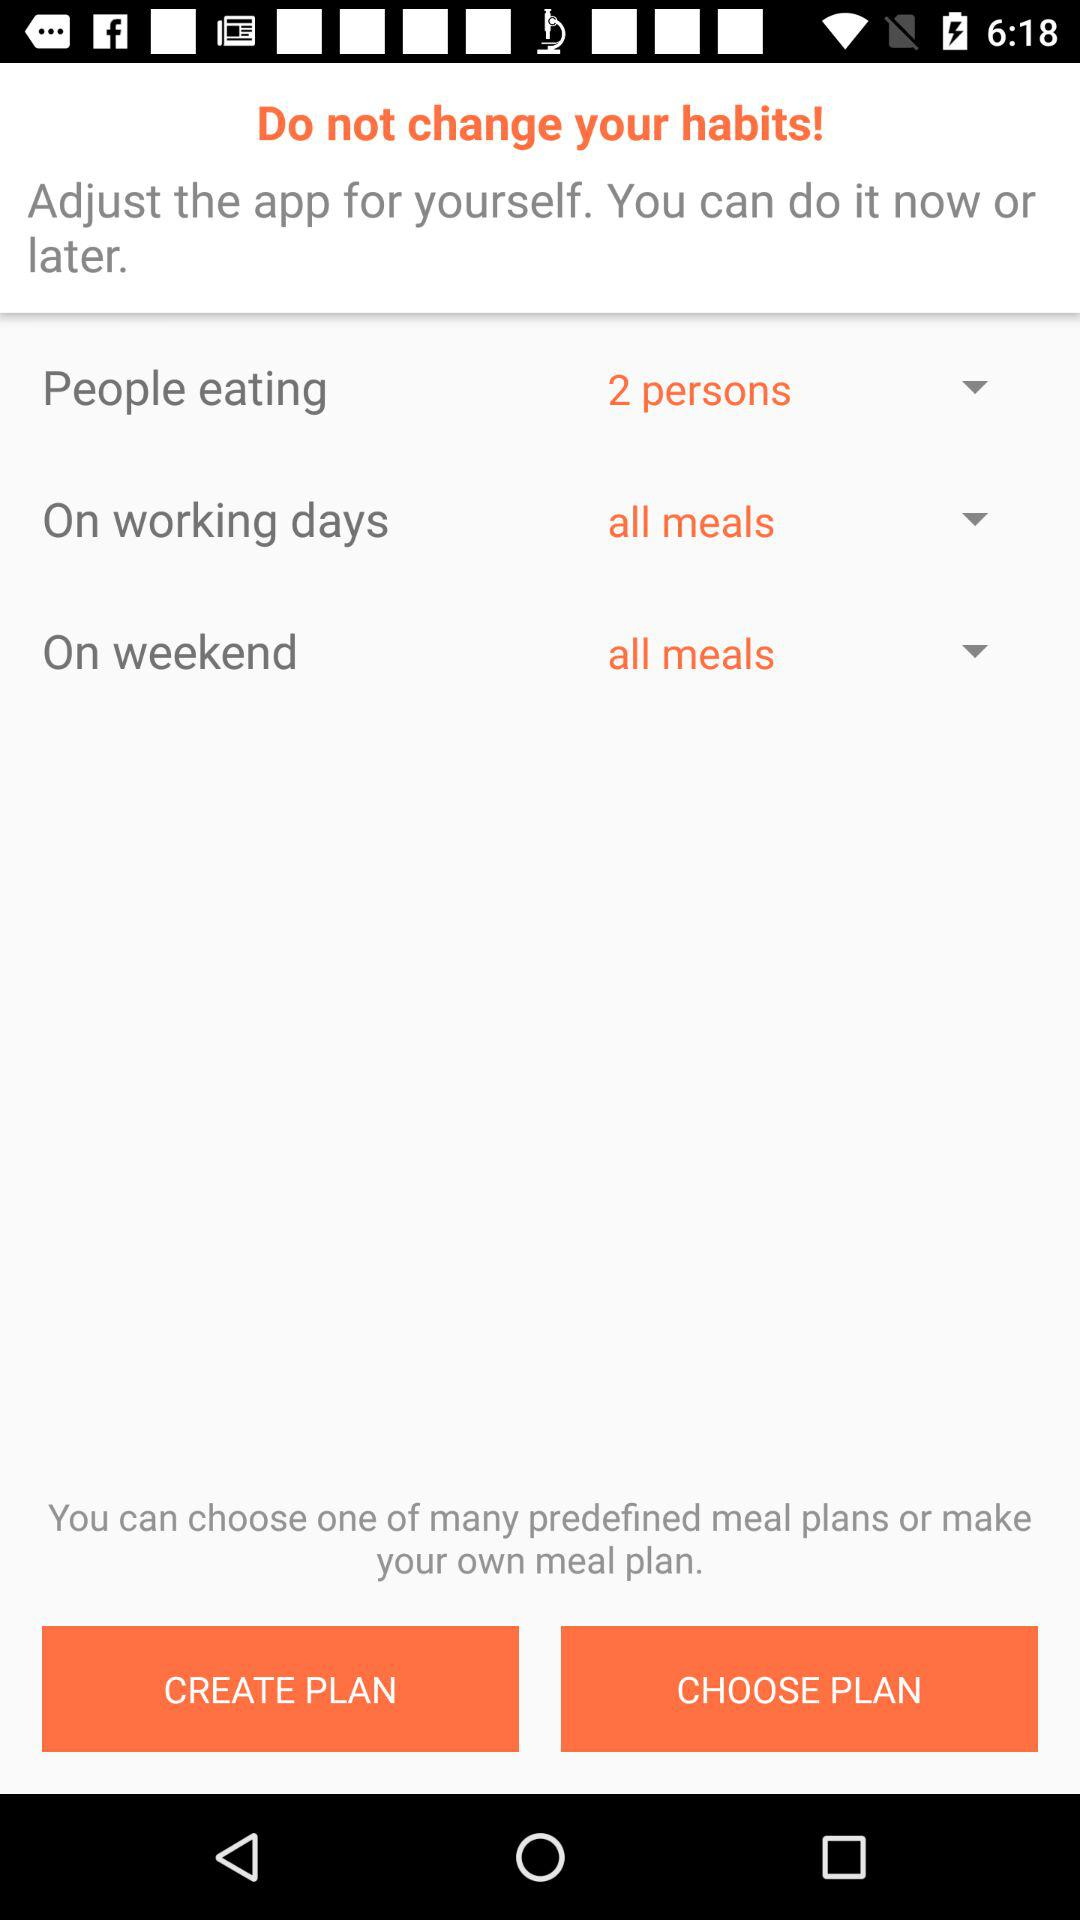Which option is selected for "People eating"? The selected option for "People eating" is "2 persons". 